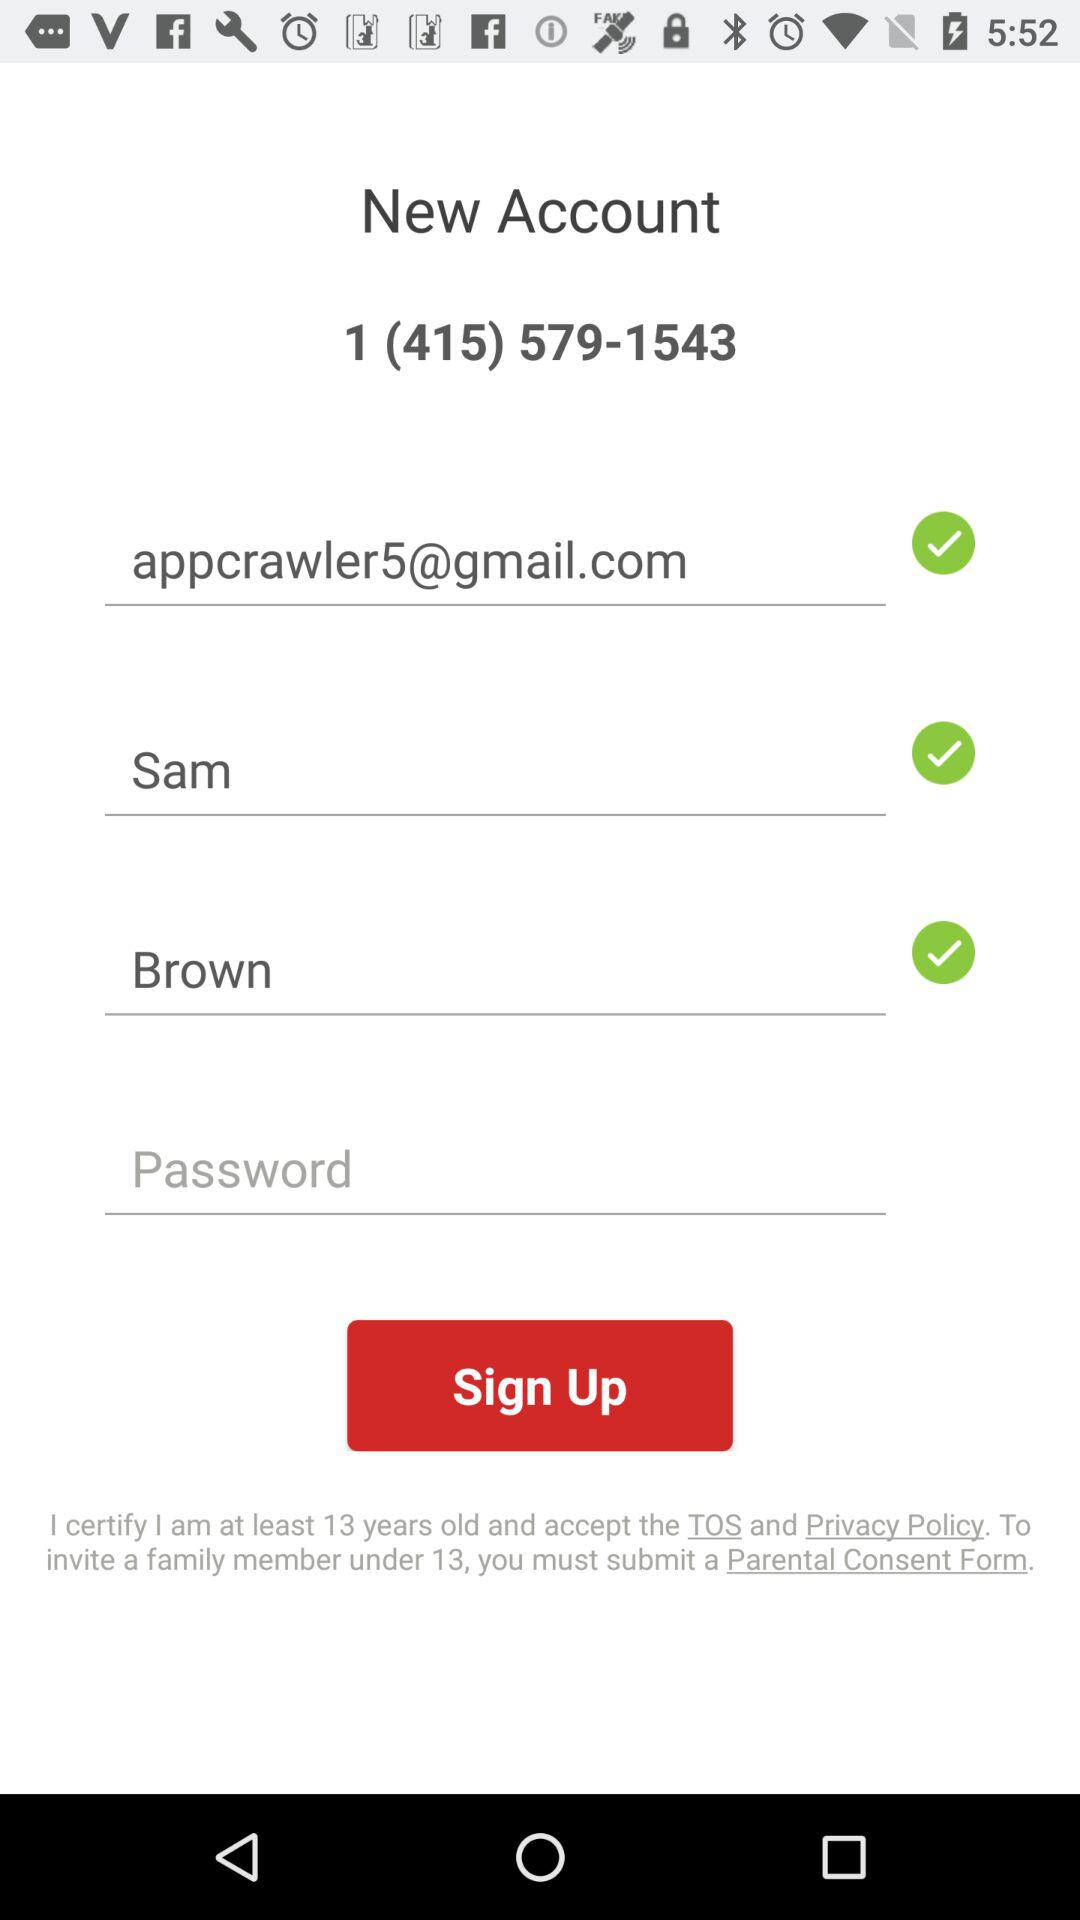What is the email address? The email address is appcrawler5@gmail.com. 